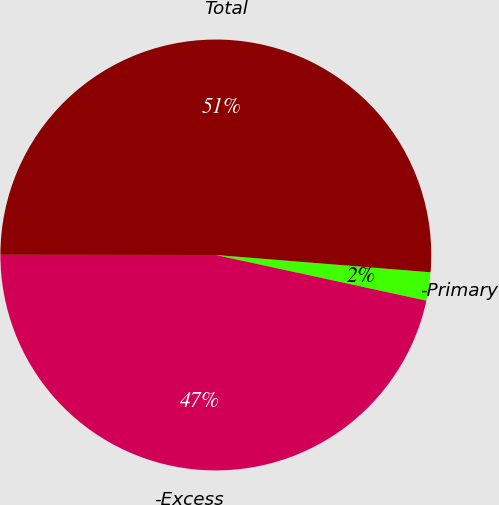<chart> <loc_0><loc_0><loc_500><loc_500><pie_chart><fcel>-Primary<fcel>-Excess<fcel>Total<nl><fcel>2.12%<fcel>46.61%<fcel>51.27%<nl></chart> 